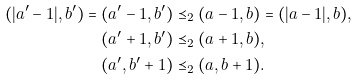Convert formula to latex. <formula><loc_0><loc_0><loc_500><loc_500>( | a ^ { \prime } - 1 | , b ^ { \prime } ) = ( a ^ { \prime } - 1 , b ^ { \prime } ) & \preceq _ { 2 } ( a - 1 , b ) = ( | a - 1 | , b ) , \\ ( a ^ { \prime } + 1 , b ^ { \prime } ) & \preceq _ { 2 } ( a + 1 , b ) , \\ ( a ^ { \prime } , b ^ { \prime } + 1 ) & \preceq _ { 2 } ( a , b + 1 ) .</formula> 